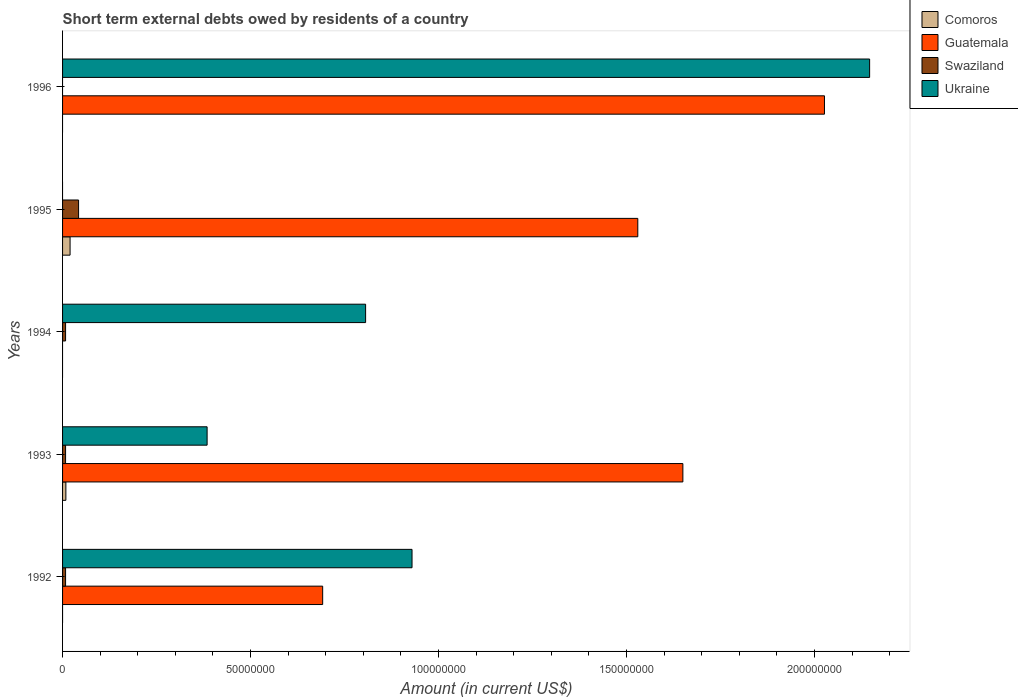How many bars are there on the 5th tick from the top?
Offer a terse response. 3. In how many cases, is the number of bars for a given year not equal to the number of legend labels?
Provide a short and direct response. 4. What is the amount of short-term external debts owed by residents in Swaziland in 1993?
Make the answer very short. 8.00e+05. Across all years, what is the maximum amount of short-term external debts owed by residents in Comoros?
Give a very brief answer. 2.00e+06. Across all years, what is the minimum amount of short-term external debts owed by residents in Guatemala?
Keep it short and to the point. 0. What is the total amount of short-term external debts owed by residents in Comoros in the graph?
Provide a short and direct response. 2.88e+06. What is the difference between the amount of short-term external debts owed by residents in Guatemala in 1993 and that in 1996?
Give a very brief answer. -3.77e+07. What is the difference between the amount of short-term external debts owed by residents in Swaziland in 1993 and the amount of short-term external debts owed by residents in Guatemala in 1996?
Make the answer very short. -2.02e+08. What is the average amount of short-term external debts owed by residents in Swaziland per year?
Make the answer very short. 1.33e+06. In the year 1995, what is the difference between the amount of short-term external debts owed by residents in Swaziland and amount of short-term external debts owed by residents in Guatemala?
Give a very brief answer. -1.49e+08. In how many years, is the amount of short-term external debts owed by residents in Ukraine greater than 130000000 US$?
Give a very brief answer. 1. What is the ratio of the amount of short-term external debts owed by residents in Guatemala in 1992 to that in 1993?
Your response must be concise. 0.42. What is the difference between the highest and the second highest amount of short-term external debts owed by residents in Swaziland?
Give a very brief answer. 3.46e+06. What is the difference between the highest and the lowest amount of short-term external debts owed by residents in Comoros?
Provide a short and direct response. 2.00e+06. In how many years, is the amount of short-term external debts owed by residents in Guatemala greater than the average amount of short-term external debts owed by residents in Guatemala taken over all years?
Your answer should be very brief. 3. Is it the case that in every year, the sum of the amount of short-term external debts owed by residents in Ukraine and amount of short-term external debts owed by residents in Swaziland is greater than the amount of short-term external debts owed by residents in Guatemala?
Your answer should be very brief. No. How many legend labels are there?
Ensure brevity in your answer.  4. What is the title of the graph?
Your response must be concise. Short term external debts owed by residents of a country. What is the label or title of the Y-axis?
Keep it short and to the point. Years. What is the Amount (in current US$) of Comoros in 1992?
Your answer should be very brief. 0. What is the Amount (in current US$) in Guatemala in 1992?
Offer a very short reply. 6.92e+07. What is the Amount (in current US$) in Ukraine in 1992?
Your answer should be very brief. 9.30e+07. What is the Amount (in current US$) of Comoros in 1993?
Make the answer very short. 8.80e+05. What is the Amount (in current US$) in Guatemala in 1993?
Make the answer very short. 1.65e+08. What is the Amount (in current US$) of Swaziland in 1993?
Your answer should be very brief. 8.00e+05. What is the Amount (in current US$) in Ukraine in 1993?
Give a very brief answer. 3.84e+07. What is the Amount (in current US$) in Ukraine in 1994?
Ensure brevity in your answer.  8.06e+07. What is the Amount (in current US$) of Comoros in 1995?
Your answer should be very brief. 2.00e+06. What is the Amount (in current US$) in Guatemala in 1995?
Ensure brevity in your answer.  1.53e+08. What is the Amount (in current US$) of Swaziland in 1995?
Your response must be concise. 4.26e+06. What is the Amount (in current US$) of Ukraine in 1995?
Offer a very short reply. 0. What is the Amount (in current US$) of Guatemala in 1996?
Provide a short and direct response. 2.03e+08. What is the Amount (in current US$) of Swaziland in 1996?
Offer a very short reply. 0. What is the Amount (in current US$) in Ukraine in 1996?
Your answer should be compact. 2.15e+08. Across all years, what is the maximum Amount (in current US$) in Guatemala?
Give a very brief answer. 2.03e+08. Across all years, what is the maximum Amount (in current US$) in Swaziland?
Make the answer very short. 4.26e+06. Across all years, what is the maximum Amount (in current US$) of Ukraine?
Offer a terse response. 2.15e+08. Across all years, what is the minimum Amount (in current US$) of Comoros?
Your response must be concise. 0. Across all years, what is the minimum Amount (in current US$) of Guatemala?
Provide a short and direct response. 0. Across all years, what is the minimum Amount (in current US$) in Swaziland?
Provide a succinct answer. 0. Across all years, what is the minimum Amount (in current US$) of Ukraine?
Give a very brief answer. 0. What is the total Amount (in current US$) of Comoros in the graph?
Ensure brevity in your answer.  2.88e+06. What is the total Amount (in current US$) in Guatemala in the graph?
Offer a very short reply. 5.90e+08. What is the total Amount (in current US$) of Swaziland in the graph?
Provide a succinct answer. 6.66e+06. What is the total Amount (in current US$) in Ukraine in the graph?
Give a very brief answer. 4.27e+08. What is the difference between the Amount (in current US$) of Guatemala in 1992 and that in 1993?
Ensure brevity in your answer.  -9.58e+07. What is the difference between the Amount (in current US$) of Swaziland in 1992 and that in 1993?
Your answer should be very brief. 0. What is the difference between the Amount (in current US$) of Ukraine in 1992 and that in 1993?
Keep it short and to the point. 5.45e+07. What is the difference between the Amount (in current US$) of Swaziland in 1992 and that in 1994?
Offer a very short reply. 0. What is the difference between the Amount (in current US$) of Ukraine in 1992 and that in 1994?
Keep it short and to the point. 1.23e+07. What is the difference between the Amount (in current US$) of Guatemala in 1992 and that in 1995?
Your answer should be very brief. -8.38e+07. What is the difference between the Amount (in current US$) of Swaziland in 1992 and that in 1995?
Offer a terse response. -3.46e+06. What is the difference between the Amount (in current US$) in Guatemala in 1992 and that in 1996?
Offer a very short reply. -1.33e+08. What is the difference between the Amount (in current US$) in Ukraine in 1992 and that in 1996?
Offer a terse response. -1.22e+08. What is the difference between the Amount (in current US$) of Ukraine in 1993 and that in 1994?
Keep it short and to the point. -4.22e+07. What is the difference between the Amount (in current US$) in Comoros in 1993 and that in 1995?
Make the answer very short. -1.12e+06. What is the difference between the Amount (in current US$) of Guatemala in 1993 and that in 1995?
Ensure brevity in your answer.  1.20e+07. What is the difference between the Amount (in current US$) in Swaziland in 1993 and that in 1995?
Your response must be concise. -3.46e+06. What is the difference between the Amount (in current US$) of Guatemala in 1993 and that in 1996?
Give a very brief answer. -3.77e+07. What is the difference between the Amount (in current US$) in Ukraine in 1993 and that in 1996?
Offer a terse response. -1.76e+08. What is the difference between the Amount (in current US$) of Swaziland in 1994 and that in 1995?
Your response must be concise. -3.46e+06. What is the difference between the Amount (in current US$) of Ukraine in 1994 and that in 1996?
Keep it short and to the point. -1.34e+08. What is the difference between the Amount (in current US$) in Guatemala in 1995 and that in 1996?
Your answer should be very brief. -4.96e+07. What is the difference between the Amount (in current US$) in Guatemala in 1992 and the Amount (in current US$) in Swaziland in 1993?
Offer a terse response. 6.84e+07. What is the difference between the Amount (in current US$) in Guatemala in 1992 and the Amount (in current US$) in Ukraine in 1993?
Keep it short and to the point. 3.07e+07. What is the difference between the Amount (in current US$) of Swaziland in 1992 and the Amount (in current US$) of Ukraine in 1993?
Offer a very short reply. -3.76e+07. What is the difference between the Amount (in current US$) in Guatemala in 1992 and the Amount (in current US$) in Swaziland in 1994?
Your answer should be very brief. 6.84e+07. What is the difference between the Amount (in current US$) of Guatemala in 1992 and the Amount (in current US$) of Ukraine in 1994?
Offer a terse response. -1.14e+07. What is the difference between the Amount (in current US$) in Swaziland in 1992 and the Amount (in current US$) in Ukraine in 1994?
Offer a terse response. -7.98e+07. What is the difference between the Amount (in current US$) in Guatemala in 1992 and the Amount (in current US$) in Swaziland in 1995?
Ensure brevity in your answer.  6.49e+07. What is the difference between the Amount (in current US$) of Guatemala in 1992 and the Amount (in current US$) of Ukraine in 1996?
Your response must be concise. -1.45e+08. What is the difference between the Amount (in current US$) in Swaziland in 1992 and the Amount (in current US$) in Ukraine in 1996?
Your answer should be compact. -2.14e+08. What is the difference between the Amount (in current US$) in Comoros in 1993 and the Amount (in current US$) in Swaziland in 1994?
Make the answer very short. 8.00e+04. What is the difference between the Amount (in current US$) of Comoros in 1993 and the Amount (in current US$) of Ukraine in 1994?
Provide a short and direct response. -7.97e+07. What is the difference between the Amount (in current US$) of Guatemala in 1993 and the Amount (in current US$) of Swaziland in 1994?
Keep it short and to the point. 1.64e+08. What is the difference between the Amount (in current US$) in Guatemala in 1993 and the Amount (in current US$) in Ukraine in 1994?
Provide a short and direct response. 8.44e+07. What is the difference between the Amount (in current US$) in Swaziland in 1993 and the Amount (in current US$) in Ukraine in 1994?
Ensure brevity in your answer.  -7.98e+07. What is the difference between the Amount (in current US$) in Comoros in 1993 and the Amount (in current US$) in Guatemala in 1995?
Give a very brief answer. -1.52e+08. What is the difference between the Amount (in current US$) of Comoros in 1993 and the Amount (in current US$) of Swaziland in 1995?
Your response must be concise. -3.38e+06. What is the difference between the Amount (in current US$) in Guatemala in 1993 and the Amount (in current US$) in Swaziland in 1995?
Offer a very short reply. 1.61e+08. What is the difference between the Amount (in current US$) of Comoros in 1993 and the Amount (in current US$) of Guatemala in 1996?
Your answer should be compact. -2.02e+08. What is the difference between the Amount (in current US$) in Comoros in 1993 and the Amount (in current US$) in Ukraine in 1996?
Keep it short and to the point. -2.14e+08. What is the difference between the Amount (in current US$) in Guatemala in 1993 and the Amount (in current US$) in Ukraine in 1996?
Make the answer very short. -4.97e+07. What is the difference between the Amount (in current US$) of Swaziland in 1993 and the Amount (in current US$) of Ukraine in 1996?
Offer a very short reply. -2.14e+08. What is the difference between the Amount (in current US$) in Swaziland in 1994 and the Amount (in current US$) in Ukraine in 1996?
Provide a succinct answer. -2.14e+08. What is the difference between the Amount (in current US$) of Comoros in 1995 and the Amount (in current US$) of Guatemala in 1996?
Provide a succinct answer. -2.01e+08. What is the difference between the Amount (in current US$) of Comoros in 1995 and the Amount (in current US$) of Ukraine in 1996?
Offer a very short reply. -2.13e+08. What is the difference between the Amount (in current US$) of Guatemala in 1995 and the Amount (in current US$) of Ukraine in 1996?
Give a very brief answer. -6.17e+07. What is the difference between the Amount (in current US$) in Swaziland in 1995 and the Amount (in current US$) in Ukraine in 1996?
Offer a terse response. -2.10e+08. What is the average Amount (in current US$) in Comoros per year?
Ensure brevity in your answer.  5.76e+05. What is the average Amount (in current US$) of Guatemala per year?
Give a very brief answer. 1.18e+08. What is the average Amount (in current US$) of Swaziland per year?
Make the answer very short. 1.33e+06. What is the average Amount (in current US$) of Ukraine per year?
Provide a succinct answer. 8.53e+07. In the year 1992, what is the difference between the Amount (in current US$) in Guatemala and Amount (in current US$) in Swaziland?
Give a very brief answer. 6.84e+07. In the year 1992, what is the difference between the Amount (in current US$) in Guatemala and Amount (in current US$) in Ukraine?
Offer a terse response. -2.38e+07. In the year 1992, what is the difference between the Amount (in current US$) of Swaziland and Amount (in current US$) of Ukraine?
Provide a short and direct response. -9.22e+07. In the year 1993, what is the difference between the Amount (in current US$) in Comoros and Amount (in current US$) in Guatemala?
Keep it short and to the point. -1.64e+08. In the year 1993, what is the difference between the Amount (in current US$) in Comoros and Amount (in current US$) in Ukraine?
Give a very brief answer. -3.76e+07. In the year 1993, what is the difference between the Amount (in current US$) of Guatemala and Amount (in current US$) of Swaziland?
Offer a terse response. 1.64e+08. In the year 1993, what is the difference between the Amount (in current US$) in Guatemala and Amount (in current US$) in Ukraine?
Give a very brief answer. 1.27e+08. In the year 1993, what is the difference between the Amount (in current US$) in Swaziland and Amount (in current US$) in Ukraine?
Ensure brevity in your answer.  -3.76e+07. In the year 1994, what is the difference between the Amount (in current US$) in Swaziland and Amount (in current US$) in Ukraine?
Ensure brevity in your answer.  -7.98e+07. In the year 1995, what is the difference between the Amount (in current US$) in Comoros and Amount (in current US$) in Guatemala?
Your answer should be very brief. -1.51e+08. In the year 1995, what is the difference between the Amount (in current US$) in Comoros and Amount (in current US$) in Swaziland?
Keep it short and to the point. -2.26e+06. In the year 1995, what is the difference between the Amount (in current US$) of Guatemala and Amount (in current US$) of Swaziland?
Provide a short and direct response. 1.49e+08. In the year 1996, what is the difference between the Amount (in current US$) in Guatemala and Amount (in current US$) in Ukraine?
Your answer should be very brief. -1.20e+07. What is the ratio of the Amount (in current US$) in Guatemala in 1992 to that in 1993?
Your answer should be very brief. 0.42. What is the ratio of the Amount (in current US$) in Ukraine in 1992 to that in 1993?
Your answer should be compact. 2.42. What is the ratio of the Amount (in current US$) of Swaziland in 1992 to that in 1994?
Give a very brief answer. 1. What is the ratio of the Amount (in current US$) in Ukraine in 1992 to that in 1994?
Offer a very short reply. 1.15. What is the ratio of the Amount (in current US$) of Guatemala in 1992 to that in 1995?
Provide a short and direct response. 0.45. What is the ratio of the Amount (in current US$) in Swaziland in 1992 to that in 1995?
Your answer should be very brief. 0.19. What is the ratio of the Amount (in current US$) of Guatemala in 1992 to that in 1996?
Keep it short and to the point. 0.34. What is the ratio of the Amount (in current US$) in Ukraine in 1992 to that in 1996?
Offer a terse response. 0.43. What is the ratio of the Amount (in current US$) of Swaziland in 1993 to that in 1994?
Your answer should be compact. 1. What is the ratio of the Amount (in current US$) of Ukraine in 1993 to that in 1994?
Offer a terse response. 0.48. What is the ratio of the Amount (in current US$) in Comoros in 1993 to that in 1995?
Keep it short and to the point. 0.44. What is the ratio of the Amount (in current US$) in Guatemala in 1993 to that in 1995?
Make the answer very short. 1.08. What is the ratio of the Amount (in current US$) in Swaziland in 1993 to that in 1995?
Your answer should be very brief. 0.19. What is the ratio of the Amount (in current US$) in Guatemala in 1993 to that in 1996?
Provide a short and direct response. 0.81. What is the ratio of the Amount (in current US$) of Ukraine in 1993 to that in 1996?
Offer a very short reply. 0.18. What is the ratio of the Amount (in current US$) in Swaziland in 1994 to that in 1995?
Your answer should be compact. 0.19. What is the ratio of the Amount (in current US$) in Ukraine in 1994 to that in 1996?
Your answer should be compact. 0.38. What is the ratio of the Amount (in current US$) of Guatemala in 1995 to that in 1996?
Keep it short and to the point. 0.76. What is the difference between the highest and the second highest Amount (in current US$) of Guatemala?
Your response must be concise. 3.77e+07. What is the difference between the highest and the second highest Amount (in current US$) in Swaziland?
Ensure brevity in your answer.  3.46e+06. What is the difference between the highest and the second highest Amount (in current US$) of Ukraine?
Your answer should be compact. 1.22e+08. What is the difference between the highest and the lowest Amount (in current US$) in Guatemala?
Ensure brevity in your answer.  2.03e+08. What is the difference between the highest and the lowest Amount (in current US$) in Swaziland?
Your response must be concise. 4.26e+06. What is the difference between the highest and the lowest Amount (in current US$) in Ukraine?
Your response must be concise. 2.15e+08. 